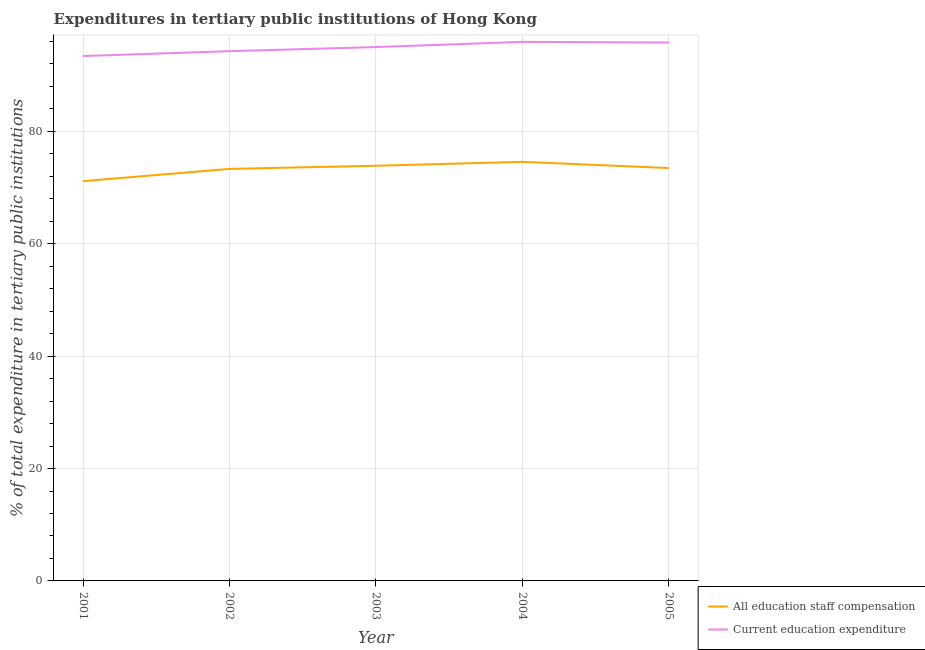How many different coloured lines are there?
Provide a succinct answer. 2. What is the expenditure in education in 2005?
Give a very brief answer. 95.81. Across all years, what is the maximum expenditure in education?
Keep it short and to the point. 95.93. Across all years, what is the minimum expenditure in staff compensation?
Your response must be concise. 71.14. In which year was the expenditure in staff compensation maximum?
Offer a very short reply. 2004. In which year was the expenditure in education minimum?
Your answer should be very brief. 2001. What is the total expenditure in staff compensation in the graph?
Offer a very short reply. 366.39. What is the difference between the expenditure in education in 2001 and that in 2004?
Ensure brevity in your answer.  -2.53. What is the difference between the expenditure in staff compensation in 2002 and the expenditure in education in 2001?
Your answer should be compact. -20.09. What is the average expenditure in staff compensation per year?
Your answer should be compact. 73.28. In the year 2004, what is the difference between the expenditure in staff compensation and expenditure in education?
Ensure brevity in your answer.  -21.35. What is the ratio of the expenditure in staff compensation in 2002 to that in 2003?
Offer a very short reply. 0.99. What is the difference between the highest and the second highest expenditure in education?
Your answer should be compact. 0.13. What is the difference between the highest and the lowest expenditure in education?
Your response must be concise. 2.53. In how many years, is the expenditure in staff compensation greater than the average expenditure in staff compensation taken over all years?
Offer a very short reply. 4. Does the expenditure in staff compensation monotonically increase over the years?
Make the answer very short. No. Is the expenditure in staff compensation strictly greater than the expenditure in education over the years?
Your answer should be very brief. No. Is the expenditure in staff compensation strictly less than the expenditure in education over the years?
Offer a terse response. Yes. How many years are there in the graph?
Your answer should be compact. 5. Are the values on the major ticks of Y-axis written in scientific E-notation?
Make the answer very short. No. Does the graph contain grids?
Keep it short and to the point. Yes. How many legend labels are there?
Provide a short and direct response. 2. How are the legend labels stacked?
Offer a terse response. Vertical. What is the title of the graph?
Your answer should be very brief. Expenditures in tertiary public institutions of Hong Kong. Does "Under-five" appear as one of the legend labels in the graph?
Your answer should be very brief. No. What is the label or title of the X-axis?
Offer a very short reply. Year. What is the label or title of the Y-axis?
Your answer should be very brief. % of total expenditure in tertiary public institutions. What is the % of total expenditure in tertiary public institutions of All education staff compensation in 2001?
Your response must be concise. 71.14. What is the % of total expenditure in tertiary public institutions of Current education expenditure in 2001?
Keep it short and to the point. 93.41. What is the % of total expenditure in tertiary public institutions of All education staff compensation in 2002?
Provide a short and direct response. 73.32. What is the % of total expenditure in tertiary public institutions of Current education expenditure in 2002?
Make the answer very short. 94.27. What is the % of total expenditure in tertiary public institutions in All education staff compensation in 2003?
Offer a very short reply. 73.88. What is the % of total expenditure in tertiary public institutions of Current education expenditure in 2003?
Provide a succinct answer. 95. What is the % of total expenditure in tertiary public institutions of All education staff compensation in 2004?
Your answer should be compact. 74.58. What is the % of total expenditure in tertiary public institutions in Current education expenditure in 2004?
Keep it short and to the point. 95.93. What is the % of total expenditure in tertiary public institutions of All education staff compensation in 2005?
Give a very brief answer. 73.47. What is the % of total expenditure in tertiary public institutions of Current education expenditure in 2005?
Provide a succinct answer. 95.81. Across all years, what is the maximum % of total expenditure in tertiary public institutions in All education staff compensation?
Your response must be concise. 74.58. Across all years, what is the maximum % of total expenditure in tertiary public institutions in Current education expenditure?
Your response must be concise. 95.93. Across all years, what is the minimum % of total expenditure in tertiary public institutions of All education staff compensation?
Your response must be concise. 71.14. Across all years, what is the minimum % of total expenditure in tertiary public institutions in Current education expenditure?
Your answer should be compact. 93.41. What is the total % of total expenditure in tertiary public institutions of All education staff compensation in the graph?
Provide a short and direct response. 366.39. What is the total % of total expenditure in tertiary public institutions of Current education expenditure in the graph?
Keep it short and to the point. 474.42. What is the difference between the % of total expenditure in tertiary public institutions in All education staff compensation in 2001 and that in 2002?
Provide a short and direct response. -2.18. What is the difference between the % of total expenditure in tertiary public institutions of Current education expenditure in 2001 and that in 2002?
Give a very brief answer. -0.87. What is the difference between the % of total expenditure in tertiary public institutions of All education staff compensation in 2001 and that in 2003?
Your answer should be very brief. -2.74. What is the difference between the % of total expenditure in tertiary public institutions of Current education expenditure in 2001 and that in 2003?
Ensure brevity in your answer.  -1.6. What is the difference between the % of total expenditure in tertiary public institutions of All education staff compensation in 2001 and that in 2004?
Offer a very short reply. -3.44. What is the difference between the % of total expenditure in tertiary public institutions of Current education expenditure in 2001 and that in 2004?
Your response must be concise. -2.53. What is the difference between the % of total expenditure in tertiary public institutions in All education staff compensation in 2001 and that in 2005?
Your answer should be compact. -2.33. What is the difference between the % of total expenditure in tertiary public institutions in Current education expenditure in 2001 and that in 2005?
Your answer should be very brief. -2.4. What is the difference between the % of total expenditure in tertiary public institutions of All education staff compensation in 2002 and that in 2003?
Ensure brevity in your answer.  -0.56. What is the difference between the % of total expenditure in tertiary public institutions in Current education expenditure in 2002 and that in 2003?
Your answer should be compact. -0.73. What is the difference between the % of total expenditure in tertiary public institutions of All education staff compensation in 2002 and that in 2004?
Provide a succinct answer. -1.26. What is the difference between the % of total expenditure in tertiary public institutions of Current education expenditure in 2002 and that in 2004?
Your answer should be very brief. -1.66. What is the difference between the % of total expenditure in tertiary public institutions of All education staff compensation in 2002 and that in 2005?
Your answer should be very brief. -0.15. What is the difference between the % of total expenditure in tertiary public institutions in Current education expenditure in 2002 and that in 2005?
Offer a terse response. -1.54. What is the difference between the % of total expenditure in tertiary public institutions in All education staff compensation in 2003 and that in 2004?
Your answer should be compact. -0.7. What is the difference between the % of total expenditure in tertiary public institutions of Current education expenditure in 2003 and that in 2004?
Provide a succinct answer. -0.93. What is the difference between the % of total expenditure in tertiary public institutions in All education staff compensation in 2003 and that in 2005?
Make the answer very short. 0.41. What is the difference between the % of total expenditure in tertiary public institutions of Current education expenditure in 2003 and that in 2005?
Keep it short and to the point. -0.8. What is the difference between the % of total expenditure in tertiary public institutions of All education staff compensation in 2004 and that in 2005?
Provide a succinct answer. 1.11. What is the difference between the % of total expenditure in tertiary public institutions in Current education expenditure in 2004 and that in 2005?
Your answer should be compact. 0.13. What is the difference between the % of total expenditure in tertiary public institutions of All education staff compensation in 2001 and the % of total expenditure in tertiary public institutions of Current education expenditure in 2002?
Provide a short and direct response. -23.13. What is the difference between the % of total expenditure in tertiary public institutions in All education staff compensation in 2001 and the % of total expenditure in tertiary public institutions in Current education expenditure in 2003?
Your answer should be compact. -23.86. What is the difference between the % of total expenditure in tertiary public institutions in All education staff compensation in 2001 and the % of total expenditure in tertiary public institutions in Current education expenditure in 2004?
Keep it short and to the point. -24.79. What is the difference between the % of total expenditure in tertiary public institutions in All education staff compensation in 2001 and the % of total expenditure in tertiary public institutions in Current education expenditure in 2005?
Make the answer very short. -24.67. What is the difference between the % of total expenditure in tertiary public institutions in All education staff compensation in 2002 and the % of total expenditure in tertiary public institutions in Current education expenditure in 2003?
Your answer should be compact. -21.68. What is the difference between the % of total expenditure in tertiary public institutions of All education staff compensation in 2002 and the % of total expenditure in tertiary public institutions of Current education expenditure in 2004?
Make the answer very short. -22.61. What is the difference between the % of total expenditure in tertiary public institutions in All education staff compensation in 2002 and the % of total expenditure in tertiary public institutions in Current education expenditure in 2005?
Offer a terse response. -22.49. What is the difference between the % of total expenditure in tertiary public institutions in All education staff compensation in 2003 and the % of total expenditure in tertiary public institutions in Current education expenditure in 2004?
Your answer should be very brief. -22.05. What is the difference between the % of total expenditure in tertiary public institutions of All education staff compensation in 2003 and the % of total expenditure in tertiary public institutions of Current education expenditure in 2005?
Offer a very short reply. -21.93. What is the difference between the % of total expenditure in tertiary public institutions in All education staff compensation in 2004 and the % of total expenditure in tertiary public institutions in Current education expenditure in 2005?
Your response must be concise. -21.23. What is the average % of total expenditure in tertiary public institutions of All education staff compensation per year?
Keep it short and to the point. 73.28. What is the average % of total expenditure in tertiary public institutions of Current education expenditure per year?
Your answer should be very brief. 94.88. In the year 2001, what is the difference between the % of total expenditure in tertiary public institutions in All education staff compensation and % of total expenditure in tertiary public institutions in Current education expenditure?
Provide a succinct answer. -22.26. In the year 2002, what is the difference between the % of total expenditure in tertiary public institutions in All education staff compensation and % of total expenditure in tertiary public institutions in Current education expenditure?
Provide a succinct answer. -20.95. In the year 2003, what is the difference between the % of total expenditure in tertiary public institutions of All education staff compensation and % of total expenditure in tertiary public institutions of Current education expenditure?
Your answer should be very brief. -21.12. In the year 2004, what is the difference between the % of total expenditure in tertiary public institutions in All education staff compensation and % of total expenditure in tertiary public institutions in Current education expenditure?
Your response must be concise. -21.35. In the year 2005, what is the difference between the % of total expenditure in tertiary public institutions in All education staff compensation and % of total expenditure in tertiary public institutions in Current education expenditure?
Ensure brevity in your answer.  -22.34. What is the ratio of the % of total expenditure in tertiary public institutions of All education staff compensation in 2001 to that in 2002?
Make the answer very short. 0.97. What is the ratio of the % of total expenditure in tertiary public institutions of Current education expenditure in 2001 to that in 2002?
Offer a terse response. 0.99. What is the ratio of the % of total expenditure in tertiary public institutions in All education staff compensation in 2001 to that in 2003?
Offer a very short reply. 0.96. What is the ratio of the % of total expenditure in tertiary public institutions in Current education expenditure in 2001 to that in 2003?
Offer a very short reply. 0.98. What is the ratio of the % of total expenditure in tertiary public institutions in All education staff compensation in 2001 to that in 2004?
Give a very brief answer. 0.95. What is the ratio of the % of total expenditure in tertiary public institutions in Current education expenditure in 2001 to that in 2004?
Provide a short and direct response. 0.97. What is the ratio of the % of total expenditure in tertiary public institutions in All education staff compensation in 2001 to that in 2005?
Provide a succinct answer. 0.97. What is the ratio of the % of total expenditure in tertiary public institutions in Current education expenditure in 2001 to that in 2005?
Provide a succinct answer. 0.97. What is the ratio of the % of total expenditure in tertiary public institutions in All education staff compensation in 2002 to that in 2003?
Ensure brevity in your answer.  0.99. What is the ratio of the % of total expenditure in tertiary public institutions in All education staff compensation in 2002 to that in 2004?
Your response must be concise. 0.98. What is the ratio of the % of total expenditure in tertiary public institutions of Current education expenditure in 2002 to that in 2004?
Provide a short and direct response. 0.98. What is the ratio of the % of total expenditure in tertiary public institutions in All education staff compensation in 2002 to that in 2005?
Your answer should be very brief. 1. What is the ratio of the % of total expenditure in tertiary public institutions of All education staff compensation in 2003 to that in 2004?
Your answer should be compact. 0.99. What is the ratio of the % of total expenditure in tertiary public institutions of Current education expenditure in 2003 to that in 2004?
Keep it short and to the point. 0.99. What is the ratio of the % of total expenditure in tertiary public institutions in All education staff compensation in 2003 to that in 2005?
Keep it short and to the point. 1.01. What is the ratio of the % of total expenditure in tertiary public institutions of All education staff compensation in 2004 to that in 2005?
Keep it short and to the point. 1.02. What is the ratio of the % of total expenditure in tertiary public institutions in Current education expenditure in 2004 to that in 2005?
Your answer should be compact. 1. What is the difference between the highest and the second highest % of total expenditure in tertiary public institutions of All education staff compensation?
Provide a short and direct response. 0.7. What is the difference between the highest and the second highest % of total expenditure in tertiary public institutions of Current education expenditure?
Keep it short and to the point. 0.13. What is the difference between the highest and the lowest % of total expenditure in tertiary public institutions of All education staff compensation?
Your answer should be compact. 3.44. What is the difference between the highest and the lowest % of total expenditure in tertiary public institutions in Current education expenditure?
Ensure brevity in your answer.  2.53. 